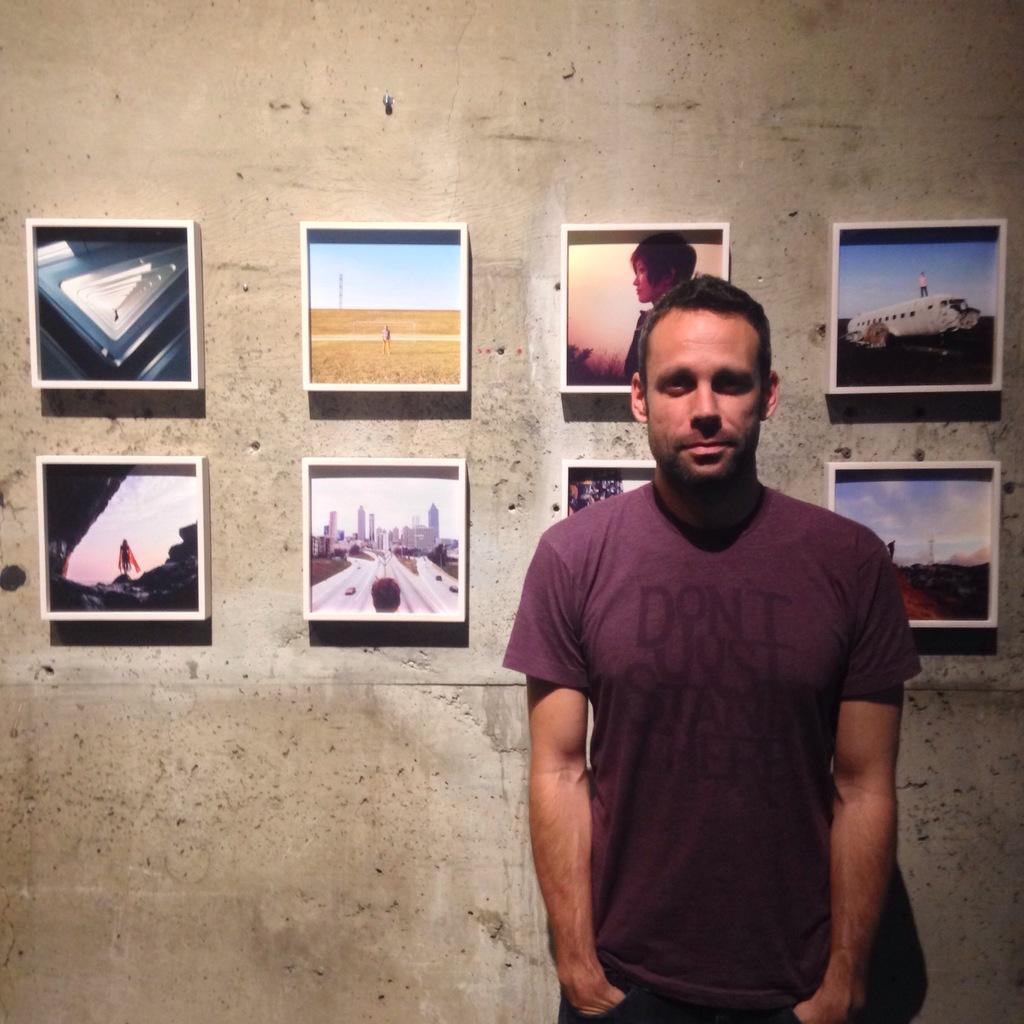How would you summarize this image in a sentence or two? In the foreground of this picture, there is a man standing near a wall. In the background, there are frames attached to the wall. 